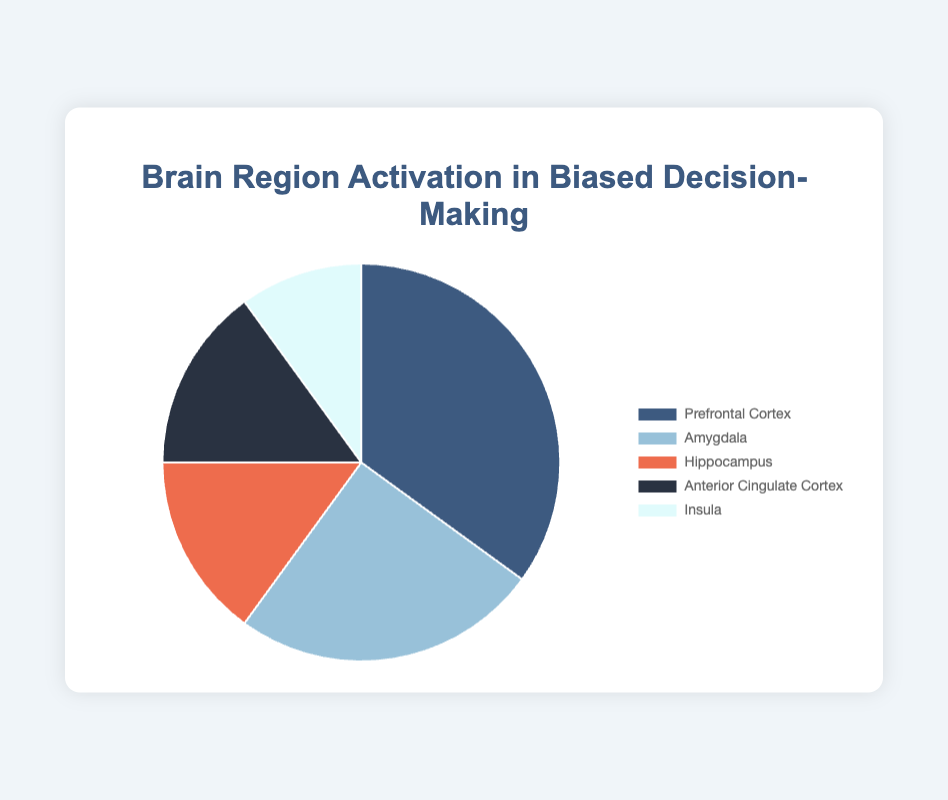What percentage of brain regions are activated for both the hippocampus and the insula? To find this, add the activation percentages of the hippocampus and the insula. The hippocampus activation is 15%, and the insula activation is 10%. Therefore, the sum is 15% + 10% = 25%.
Answer: 25% Which brain region has the highest activation percentage in biased decision-making? By examining the percentages, we see that the prefrontal cortex has the highest activation percentage at 35%.
Answer: Prefrontal Cortex How does the activation percentage of the amygdala compare to the anterior cingulate cortex? The amygdala has an activation percentage of 25%, while the anterior cingulate cortex has 15%. Therefore, the amygdala's activation percentage is higher than that of the anterior cingulate cortex.
Answer: Amygdala is higher What is the difference in activation percentage between the prefrontal cortex and the insula? To find this difference, subtract the insula's activation percentage (10%) from the prefrontal cortex's activation percentage (35%). 35% - 10% = 25%.
Answer: 25% If we sum the activation percentages of the anterior cingulate cortex and the hippocampus, what percentage do we get? The anterior cingulate cortex has an activation percentage of 15%, and the hippocampus also has 15%. Their sum is 15% + 15% = 30%.
Answer: 30% Which brain region is represented by light blue color? The chart visually assigns colors to different regions. Light blue is associated with the amygdala.
Answer: Amygdala Between the hippocampus and the amygdala, which region has a lower activation percentage, and by how much? The hippocampus has a lower activation percentage (15%) compared to the amygdala (25%). The difference is 25% - 15% = 10%.
Answer: Hippocampus by 10% What percentage of brain region activation does the anterior cingulate cortex and the insula together represent, and what is their combined color representation? Add the percentages: 15% (anterior cingulate cortex) + 10% (insula) = 25%. The anterior cingulate cortex is represented by a dark color (possibly closer to black), and the insula by white. The combined color is not explicitly described.
Answer: 25% Which brain region takes up the smallest portion of the pie chart? The insula, with the smallest activation percentage of 10%, occupies the smallest portion of the pie chart.
Answer: Insula 